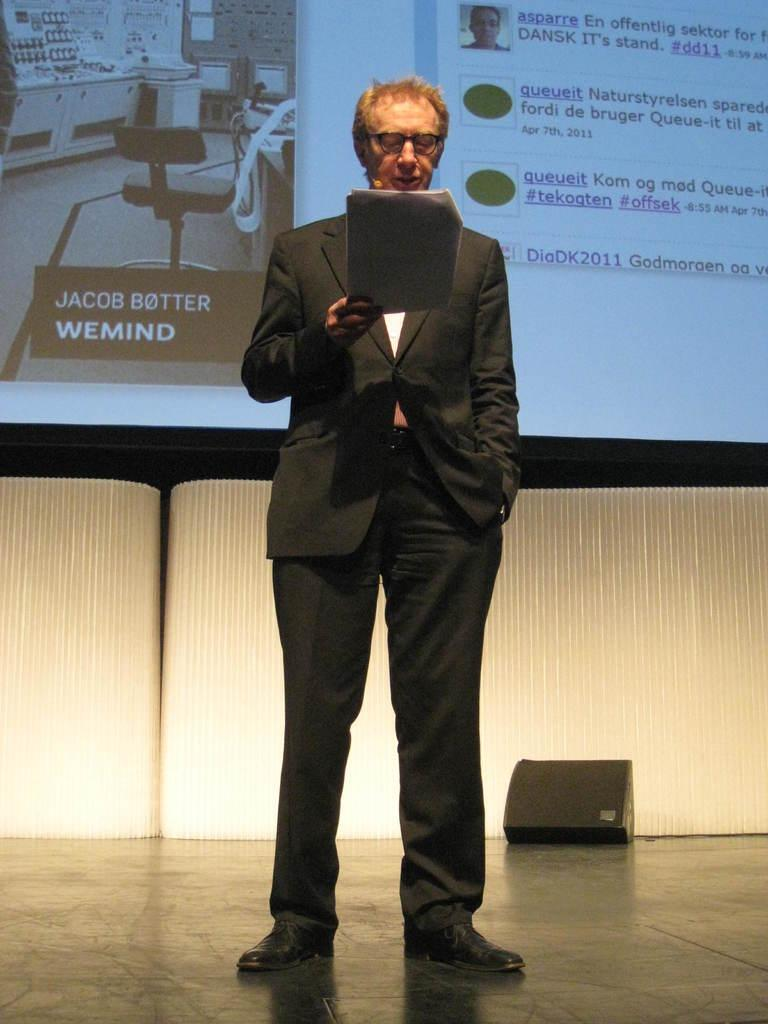What is the man in the image doing? The man is standing in the image and holding papers. What can be seen in the background of the image? There is a screen and a device on a surface in the background of the image. Can you describe the device on the surface? Unfortunately, the facts provided do not give enough detail to describe the device on the surface. What type of beef is being cooked in the oven in the image? There is no oven or beef present in the image. 